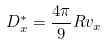Convert formula to latex. <formula><loc_0><loc_0><loc_500><loc_500>D _ { x } ^ { * } = \frac { 4 \pi } { 9 } R v _ { x }</formula> 